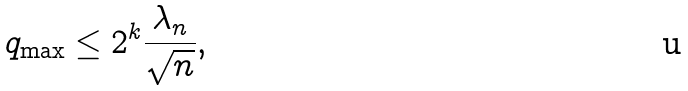Convert formula to latex. <formula><loc_0><loc_0><loc_500><loc_500>q _ { \max } \leq 2 ^ { k } \frac { \lambda _ { n } } { \sqrt { n } } ,</formula> 